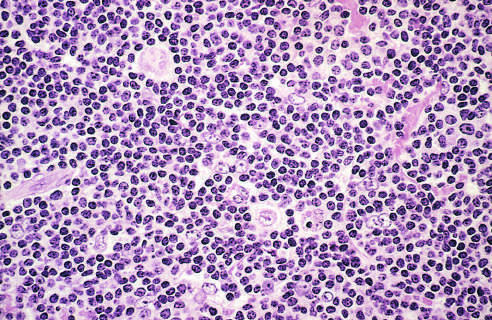what surround scattered, large, pale-staining lymphocytic and histiocytic variants popcorn cells?
Answer the question using a single word or phrase. Numerous mature-looking lymphocytes 